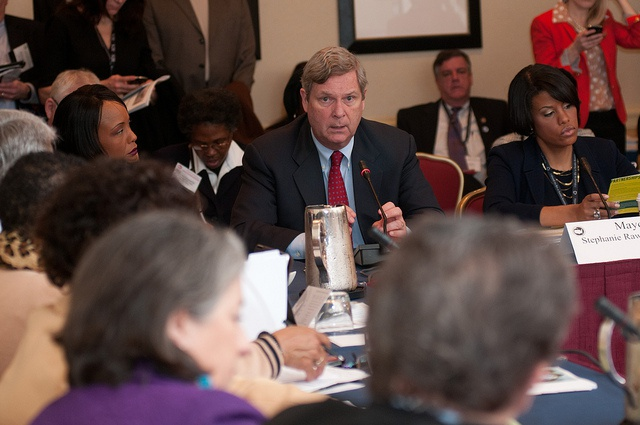Describe the objects in this image and their specific colors. I can see people in maroon, black, gray, and purple tones, people in maroon, gray, and black tones, people in maroon, black, brown, and gray tones, people in maroon, black, and brown tones, and people in maroon, black, and gray tones in this image. 